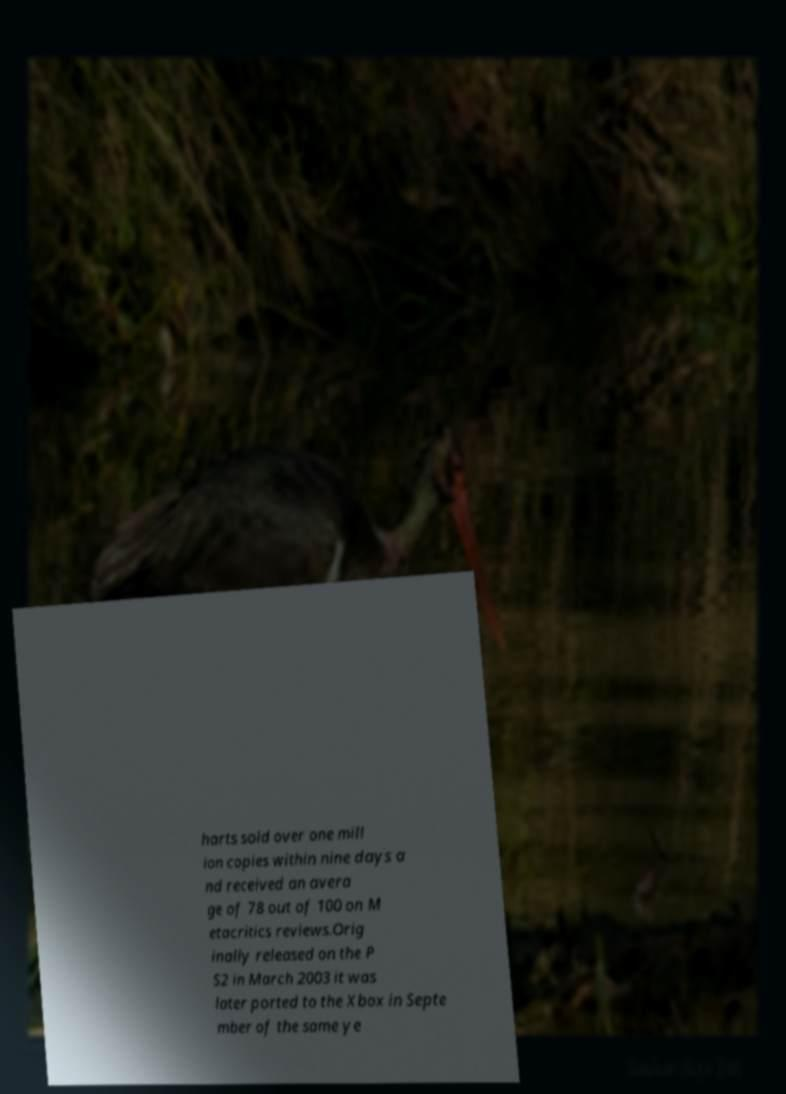Can you accurately transcribe the text from the provided image for me? harts sold over one mill ion copies within nine days a nd received an avera ge of 78 out of 100 on M etacritics reviews.Orig inally released on the P S2 in March 2003 it was later ported to the Xbox in Septe mber of the same ye 